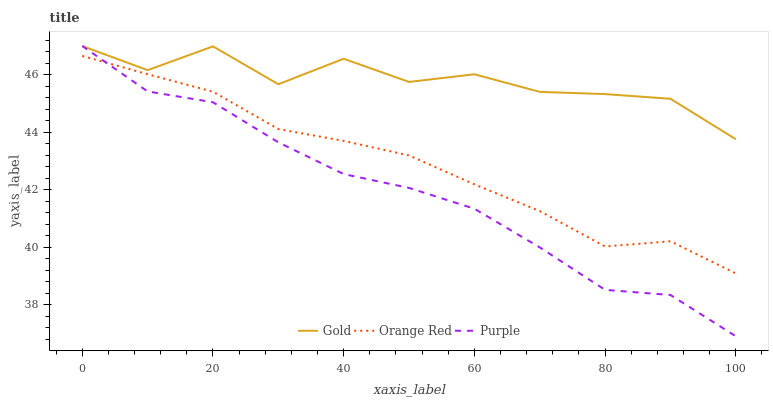Does Purple have the minimum area under the curve?
Answer yes or no. Yes. Does Gold have the maximum area under the curve?
Answer yes or no. Yes. Does Orange Red have the minimum area under the curve?
Answer yes or no. No. Does Orange Red have the maximum area under the curve?
Answer yes or no. No. Is Orange Red the smoothest?
Answer yes or no. Yes. Is Gold the roughest?
Answer yes or no. Yes. Is Gold the smoothest?
Answer yes or no. No. Is Orange Red the roughest?
Answer yes or no. No. Does Purple have the lowest value?
Answer yes or no. Yes. Does Orange Red have the lowest value?
Answer yes or no. No. Does Gold have the highest value?
Answer yes or no. Yes. Does Orange Red have the highest value?
Answer yes or no. No. Is Orange Red less than Gold?
Answer yes or no. Yes. Is Gold greater than Orange Red?
Answer yes or no. Yes. Does Purple intersect Gold?
Answer yes or no. Yes. Is Purple less than Gold?
Answer yes or no. No. Is Purple greater than Gold?
Answer yes or no. No. Does Orange Red intersect Gold?
Answer yes or no. No. 